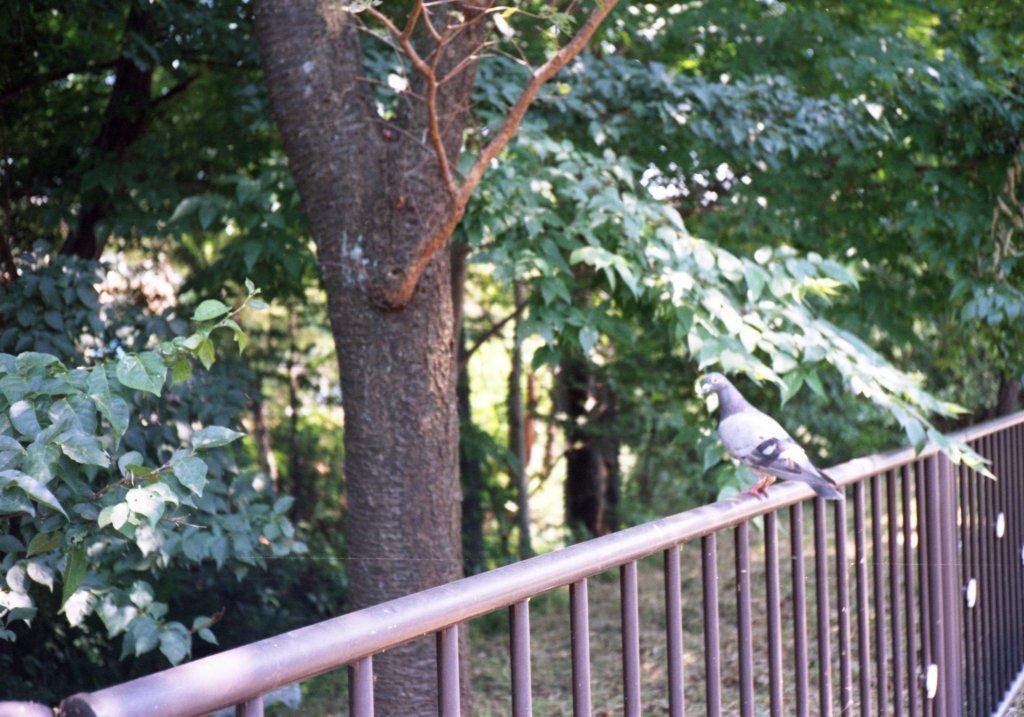How would you summarize this image in a sentence or two? In this image we can see a bird standing on the railing and there are some trees. 